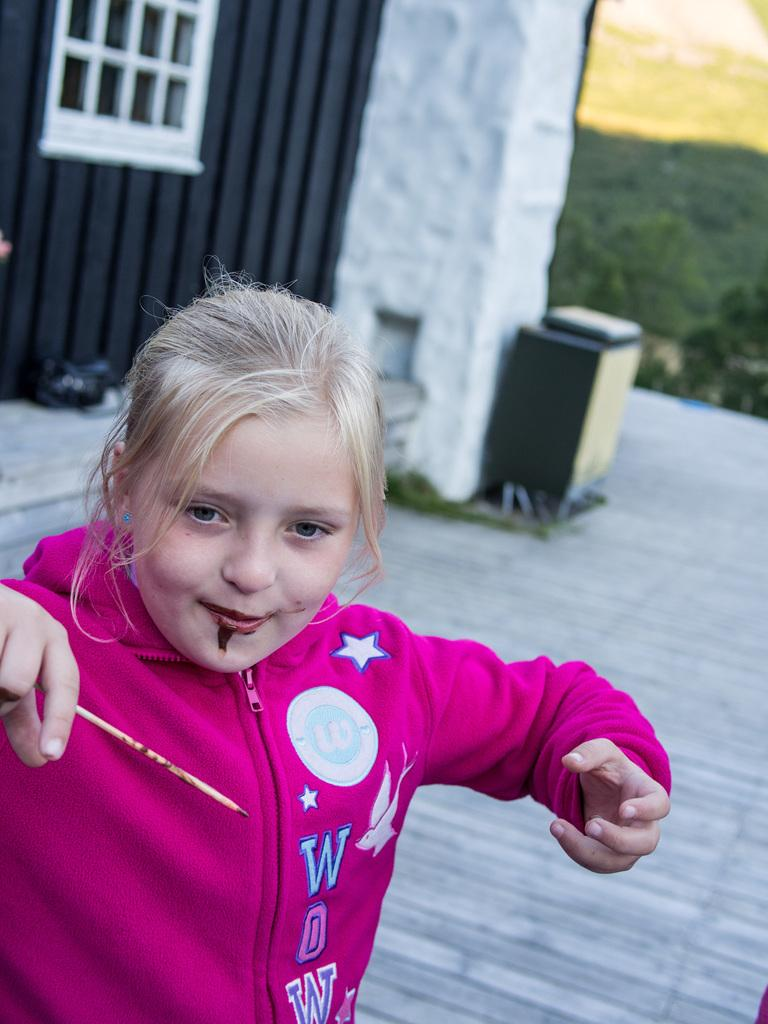<image>
Write a terse but informative summary of the picture. A young blonde girl is wearing a hot pink hoodie that says WOW. 